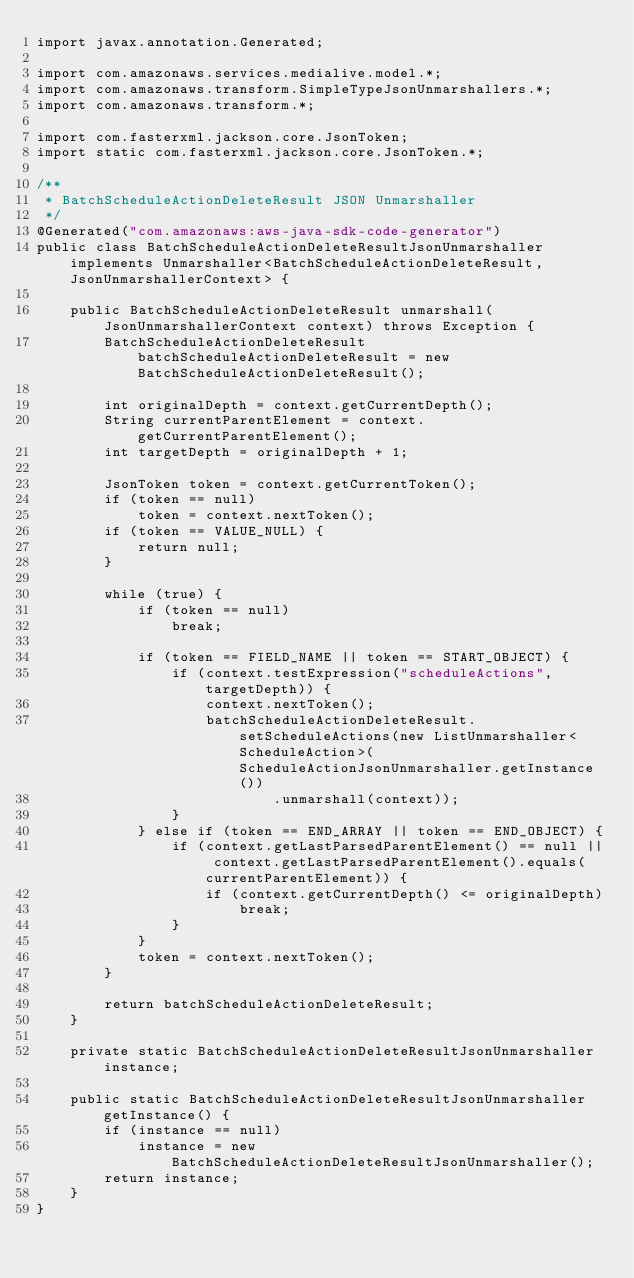<code> <loc_0><loc_0><loc_500><loc_500><_Java_>import javax.annotation.Generated;

import com.amazonaws.services.medialive.model.*;
import com.amazonaws.transform.SimpleTypeJsonUnmarshallers.*;
import com.amazonaws.transform.*;

import com.fasterxml.jackson.core.JsonToken;
import static com.fasterxml.jackson.core.JsonToken.*;

/**
 * BatchScheduleActionDeleteResult JSON Unmarshaller
 */
@Generated("com.amazonaws:aws-java-sdk-code-generator")
public class BatchScheduleActionDeleteResultJsonUnmarshaller implements Unmarshaller<BatchScheduleActionDeleteResult, JsonUnmarshallerContext> {

    public BatchScheduleActionDeleteResult unmarshall(JsonUnmarshallerContext context) throws Exception {
        BatchScheduleActionDeleteResult batchScheduleActionDeleteResult = new BatchScheduleActionDeleteResult();

        int originalDepth = context.getCurrentDepth();
        String currentParentElement = context.getCurrentParentElement();
        int targetDepth = originalDepth + 1;

        JsonToken token = context.getCurrentToken();
        if (token == null)
            token = context.nextToken();
        if (token == VALUE_NULL) {
            return null;
        }

        while (true) {
            if (token == null)
                break;

            if (token == FIELD_NAME || token == START_OBJECT) {
                if (context.testExpression("scheduleActions", targetDepth)) {
                    context.nextToken();
                    batchScheduleActionDeleteResult.setScheduleActions(new ListUnmarshaller<ScheduleAction>(ScheduleActionJsonUnmarshaller.getInstance())
                            .unmarshall(context));
                }
            } else if (token == END_ARRAY || token == END_OBJECT) {
                if (context.getLastParsedParentElement() == null || context.getLastParsedParentElement().equals(currentParentElement)) {
                    if (context.getCurrentDepth() <= originalDepth)
                        break;
                }
            }
            token = context.nextToken();
        }

        return batchScheduleActionDeleteResult;
    }

    private static BatchScheduleActionDeleteResultJsonUnmarshaller instance;

    public static BatchScheduleActionDeleteResultJsonUnmarshaller getInstance() {
        if (instance == null)
            instance = new BatchScheduleActionDeleteResultJsonUnmarshaller();
        return instance;
    }
}
</code> 